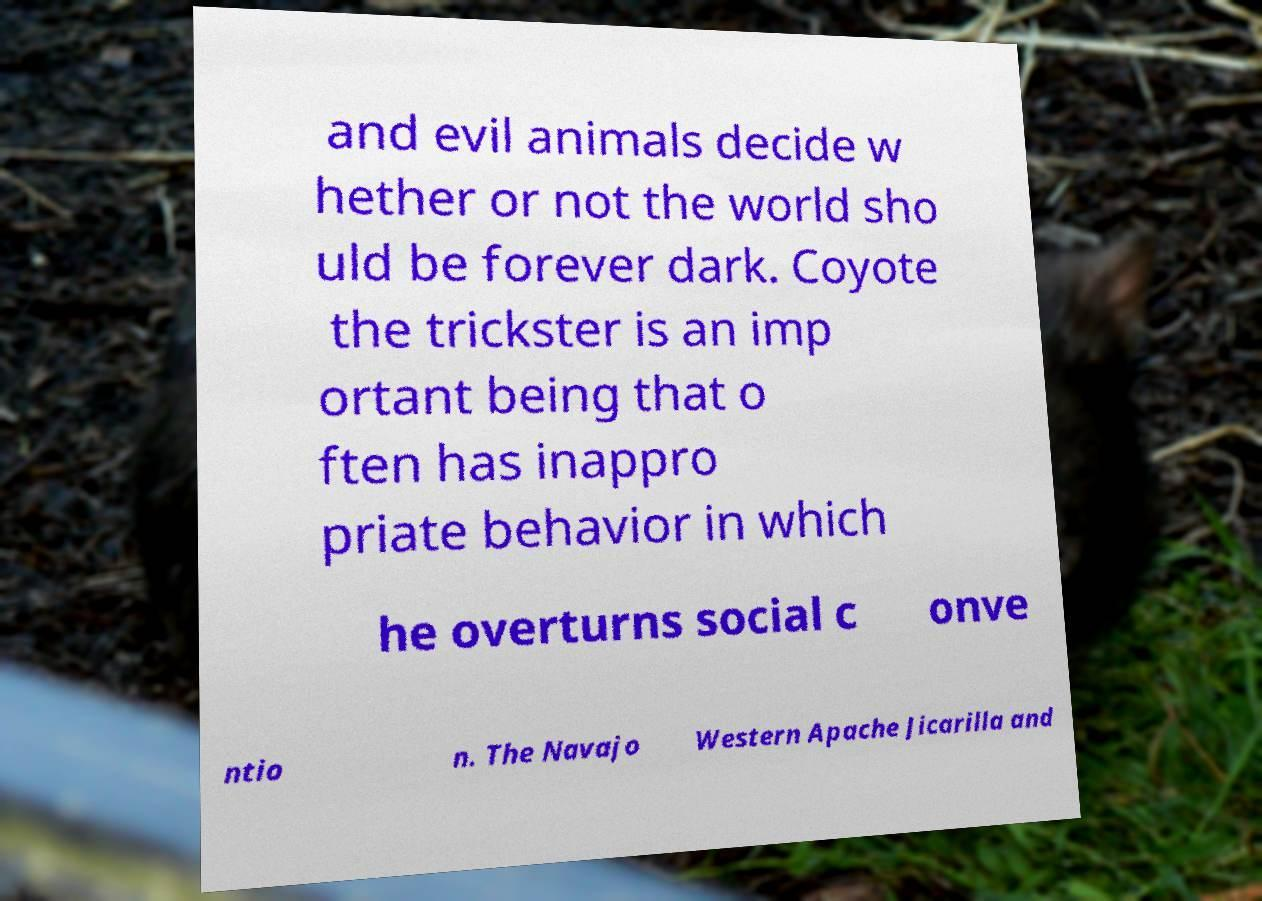What messages or text are displayed in this image? I need them in a readable, typed format. and evil animals decide w hether or not the world sho uld be forever dark. Coyote the trickster is an imp ortant being that o ften has inappro priate behavior in which he overturns social c onve ntio n. The Navajo Western Apache Jicarilla and 